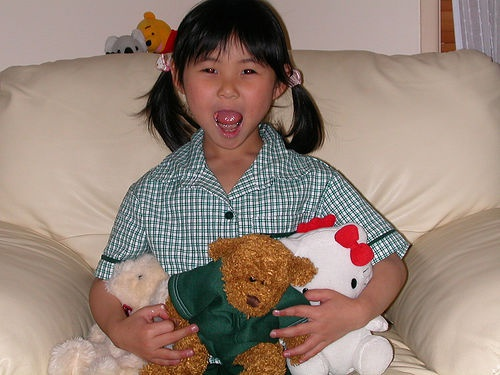Describe the objects in this image and their specific colors. I can see chair in darkgray, tan, and gray tones, people in darkgray, brown, black, and gray tones, teddy bear in darkgray, black, brown, and maroon tones, teddy bear in darkgray, tan, and gray tones, and teddy bear in darkgray, brown, maroon, and black tones in this image. 